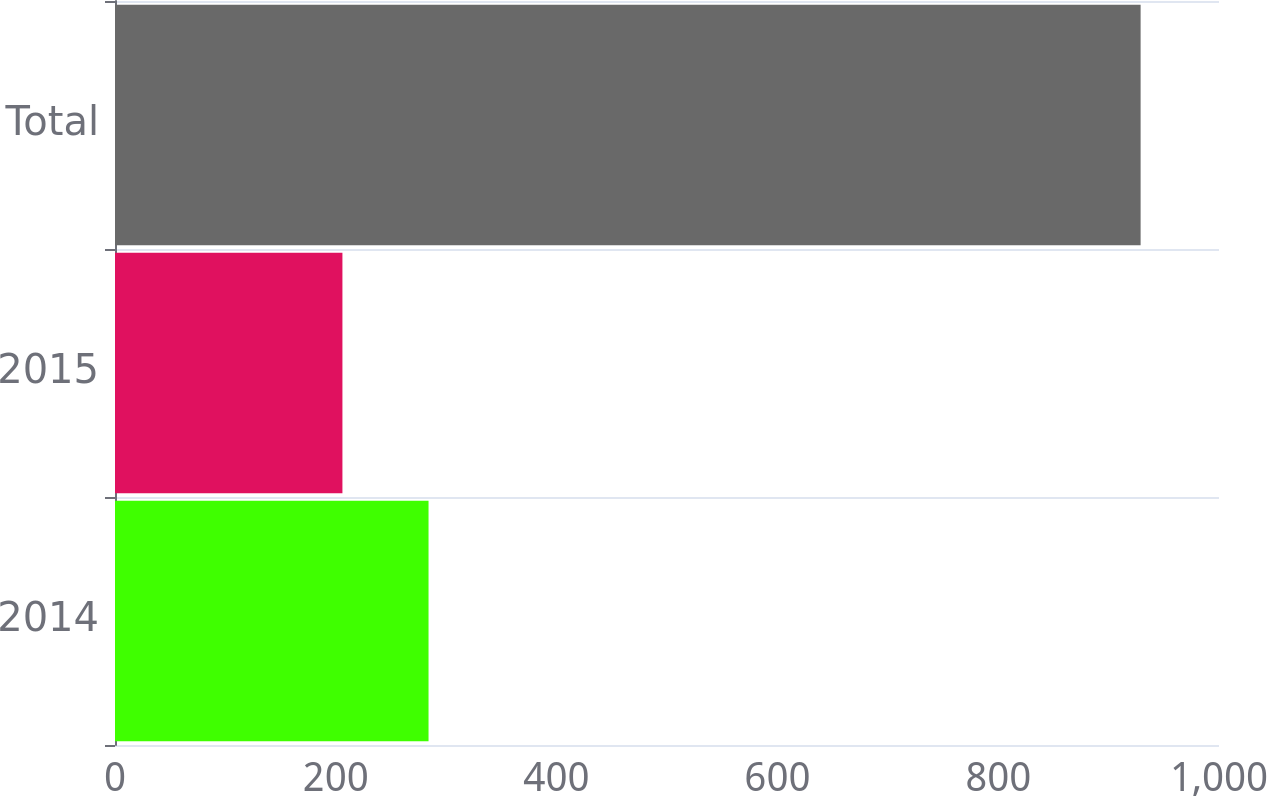Convert chart to OTSL. <chart><loc_0><loc_0><loc_500><loc_500><bar_chart><fcel>2014<fcel>2015<fcel>Total<nl><fcel>284<fcel>206<fcel>929<nl></chart> 